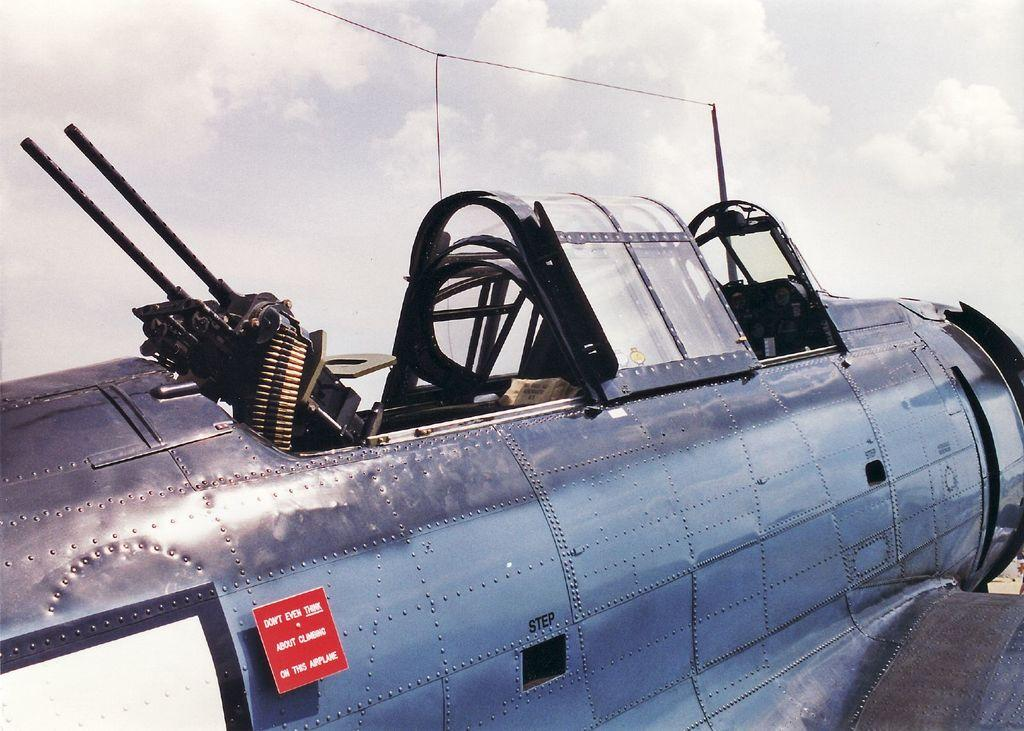What is the main subject of the image? The main subject of the image is a plane. What objects are associated with the plane in the image? There are guns, a board, a pole, and wires in the image. What can be seen in the background of the image? The sky with clouds is visible in the background of the image. What type of car can be seen driving through the clouds in the image? There is no car present in the image, and no vehicles are driving through the clouds. 